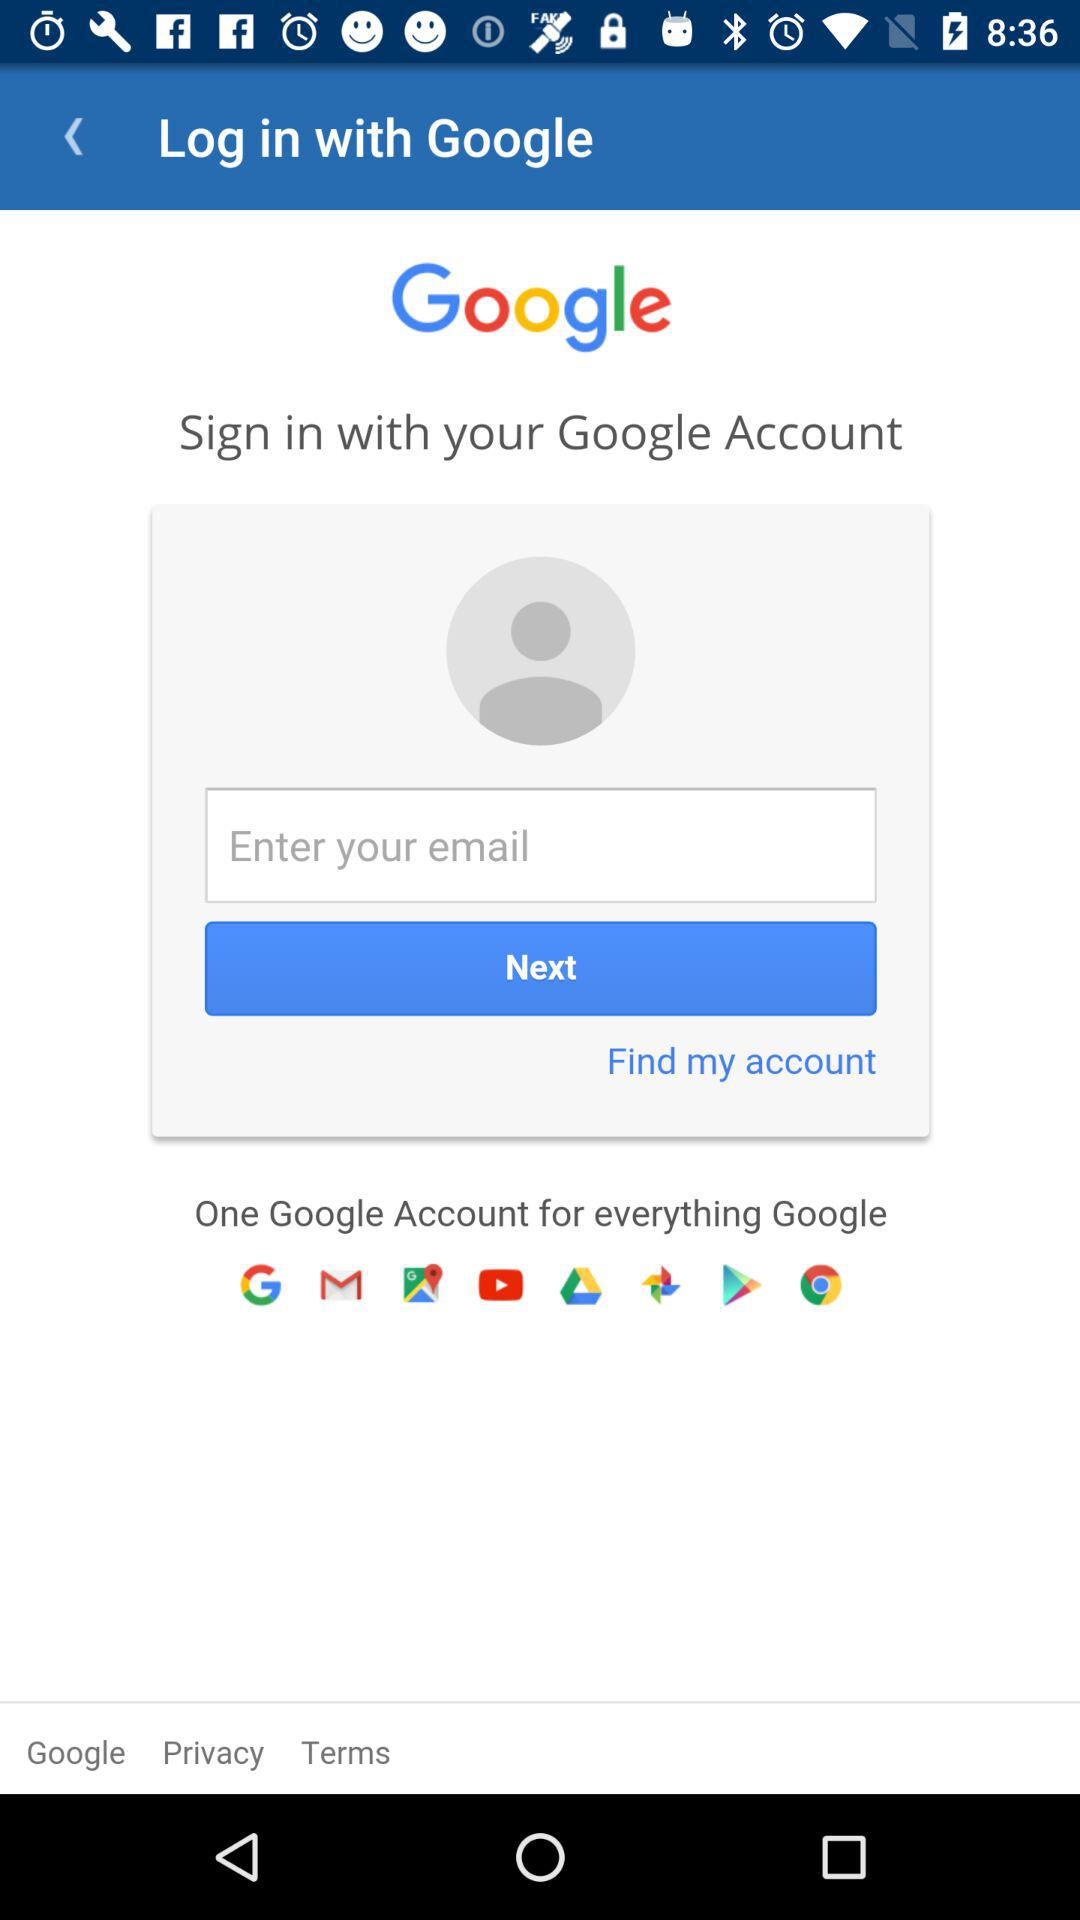Through what account can we log in? You can log in through "Google". 